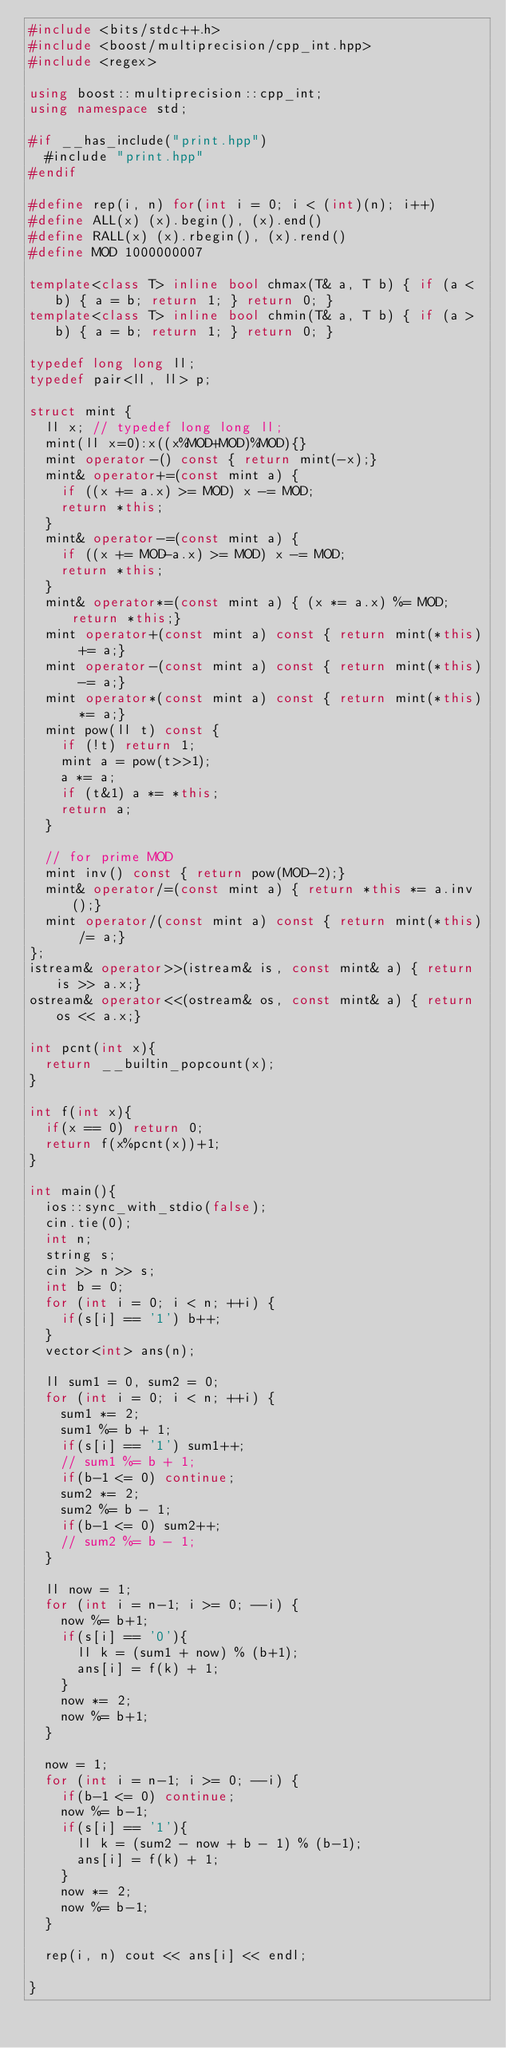Convert code to text. <code><loc_0><loc_0><loc_500><loc_500><_C++_>#include <bits/stdc++.h>
#include <boost/multiprecision/cpp_int.hpp>
#include <regex>

using boost::multiprecision::cpp_int;
using namespace std;

#if __has_include("print.hpp")
  #include "print.hpp"
#endif

#define rep(i, n) for(int i = 0; i < (int)(n); i++)
#define ALL(x) (x).begin(), (x).end()
#define RALL(x) (x).rbegin(), (x).rend()
#define MOD 1000000007

template<class T> inline bool chmax(T& a, T b) { if (a < b) { a = b; return 1; } return 0; }
template<class T> inline bool chmin(T& a, T b) { if (a > b) { a = b; return 1; } return 0; }

typedef long long ll;
typedef pair<ll, ll> p;

struct mint {
  ll x; // typedef long long ll;
  mint(ll x=0):x((x%MOD+MOD)%MOD){}
  mint operator-() const { return mint(-x);}
  mint& operator+=(const mint a) {
    if ((x += a.x) >= MOD) x -= MOD;
    return *this;
  }
  mint& operator-=(const mint a) {
    if ((x += MOD-a.x) >= MOD) x -= MOD;
    return *this;
  }
  mint& operator*=(const mint a) { (x *= a.x) %= MOD; return *this;}
  mint operator+(const mint a) const { return mint(*this) += a;}
  mint operator-(const mint a) const { return mint(*this) -= a;}
  mint operator*(const mint a) const { return mint(*this) *= a;}
  mint pow(ll t) const {
    if (!t) return 1;
    mint a = pow(t>>1);
    a *= a;
    if (t&1) a *= *this;
    return a;
  }

  // for prime MOD
  mint inv() const { return pow(MOD-2);}
  mint& operator/=(const mint a) { return *this *= a.inv();}
  mint operator/(const mint a) const { return mint(*this) /= a;}
};
istream& operator>>(istream& is, const mint& a) { return is >> a.x;}
ostream& operator<<(ostream& os, const mint& a) { return os << a.x;}

int pcnt(int x){
  return __builtin_popcount(x);
}

int f(int x){
  if(x == 0) return 0;
  return f(x%pcnt(x))+1;
}

int main(){
  ios::sync_with_stdio(false);
  cin.tie(0);
  int n;
  string s;
  cin >> n >> s;
  int b = 0;
  for (int i = 0; i < n; ++i) {
    if(s[i] == '1') b++;
  }
  vector<int> ans(n);

  ll sum1 = 0, sum2 = 0;
  for (int i = 0; i < n; ++i) {
    sum1 *= 2;
    sum1 %= b + 1;
    if(s[i] == '1') sum1++;
    // sum1 %= b + 1;
    if(b-1 <= 0) continue;
    sum2 *= 2;
    sum2 %= b - 1;
    if(b-1 <= 0) sum2++;
    // sum2 %= b - 1;
  }

  ll now = 1;
  for (int i = n-1; i >= 0; --i) {
    now %= b+1;
    if(s[i] == '0'){
      ll k = (sum1 + now) % (b+1);
      ans[i] = f(k) + 1;
    }
    now *= 2;
    now %= b+1;
  }

  now = 1;
  for (int i = n-1; i >= 0; --i) {
    if(b-1 <= 0) continue;
    now %= b-1;
    if(s[i] == '1'){
      ll k = (sum2 - now + b - 1) % (b-1);
      ans[i] = f(k) + 1;
    }
    now *= 2;
    now %= b-1;
  }

  rep(i, n) cout << ans[i] << endl;

}
</code> 